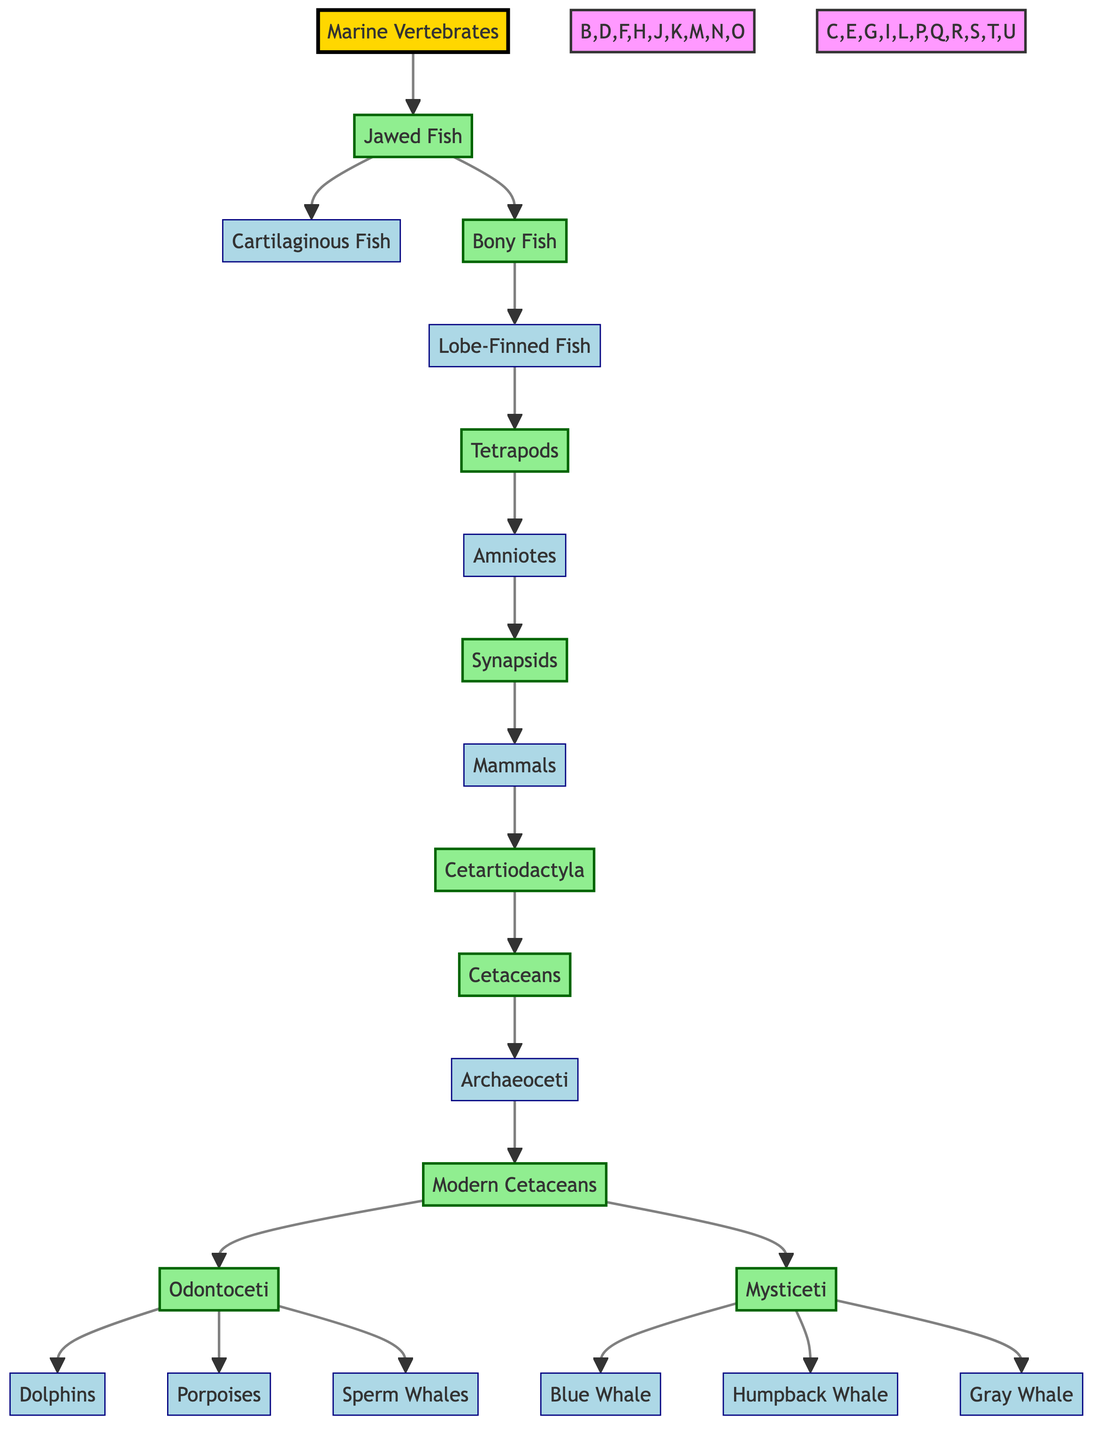What is the root of the family tree? The root node represents the most fundamental ancestor in the lineage, which is labeled "Marine Vertebrates."
Answer: Marine Vertebrates How many major groups are there under Jawed Fish? Under the node "Jawed Fish," there are two major descendants: "Cartilaginous Fish" and "Bony Fish," leading to a total of two major groups.
Answer: 2 What are the two subgroups of Modern Cetaceans? Modern Cetaceans split into two groups: "Odontoceti" and "Mysticeti," which are clearly indicated as descendants under the node "Modern Cetaceans."
Answer: Odontoceti and Mysticeti Which node directly precedes the Dolphins in the diagram? "Odontoceti," the group of Toothed Whales, is the direct parent node of "Dolphins," allowing us to trace the lineage upward to identify its immediate predecessor.
Answer: Odontoceti How many species of Baleen Whales are there listed in the diagram? The node "Mysticeti" has three descendants listed: "Blue Whale," "Humpback Whale," and "Gray Whale," thus indicating a total of three species of Baleen Whales represented in the diagram.
Answer: 3 What is the evolutionary relationship between Synapsids and Mammals? "Synapsids" is a direct ancestor to "Mammals," as shown by the direct line connecting them in the family tree, indicating that Mammals evolved from Synapsids.
Answer: Ancestor Which group contains both Dolphins and Porpoises? The group "Odontoceti," which is identified under Modern Cetaceans, includes both "Dolphins" and "Porpoises" as its descendants, showing their close evolutionary relationship.
Answer: Odontoceti Identify the highest-level taxon that includes all cetaceans. The taxon "Cetaceans" descends from "Cetartiodactyla" and represents the collective grouping of different whale species including both toothed and baleen whales.
Answer: Cetaceans How many immediate descendants does the Lobe-Finned Fish have? The "Lobe-Finned Fish" node directly leads to "Tetrapods," which is its sole descendant, indicating that there is one immediate descendant to this group.
Answer: 1 